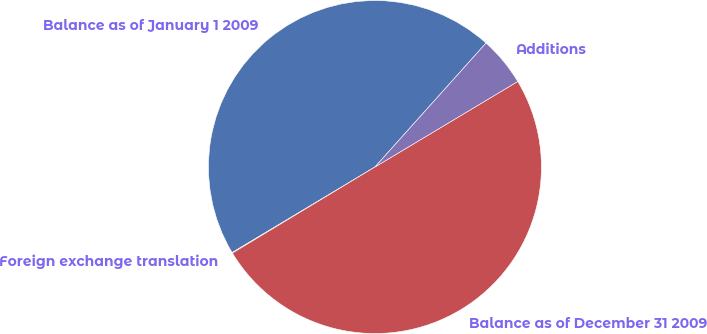<chart> <loc_0><loc_0><loc_500><loc_500><pie_chart><fcel>Balance as of January 1 2009<fcel>Foreign exchange translation<fcel>Balance as of December 31 2009<fcel>Additions<nl><fcel>45.22%<fcel>0.06%<fcel>49.94%<fcel>4.78%<nl></chart> 